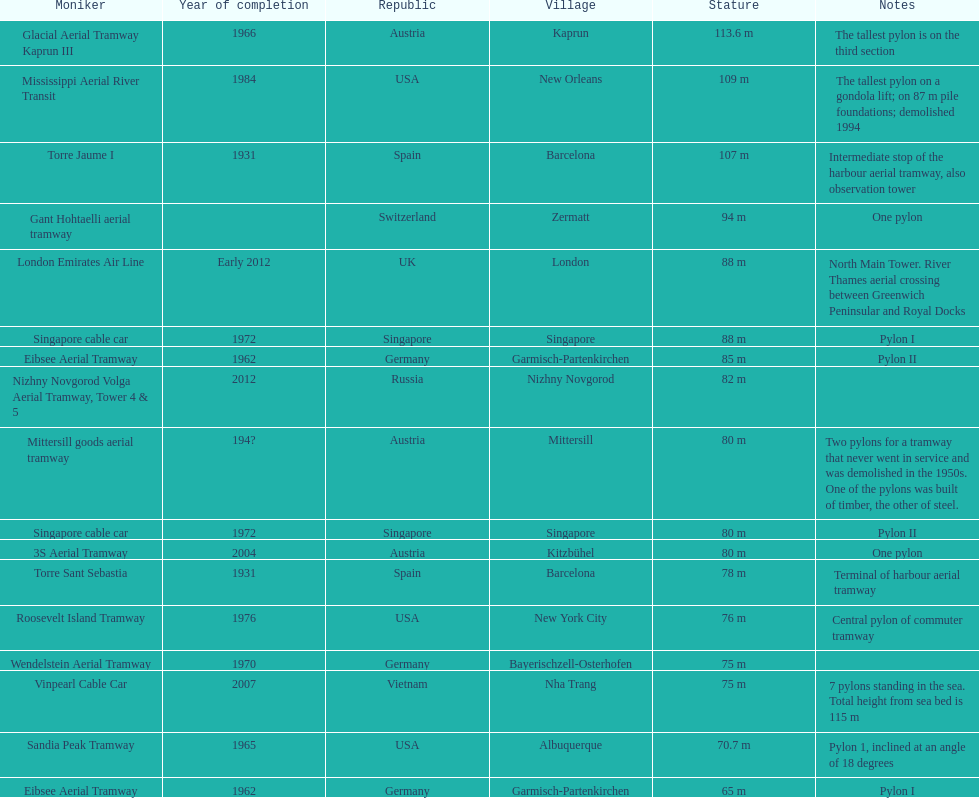List two pylons that are at most, 80 m in height. Mittersill goods aerial tramway, Singapore cable car. 